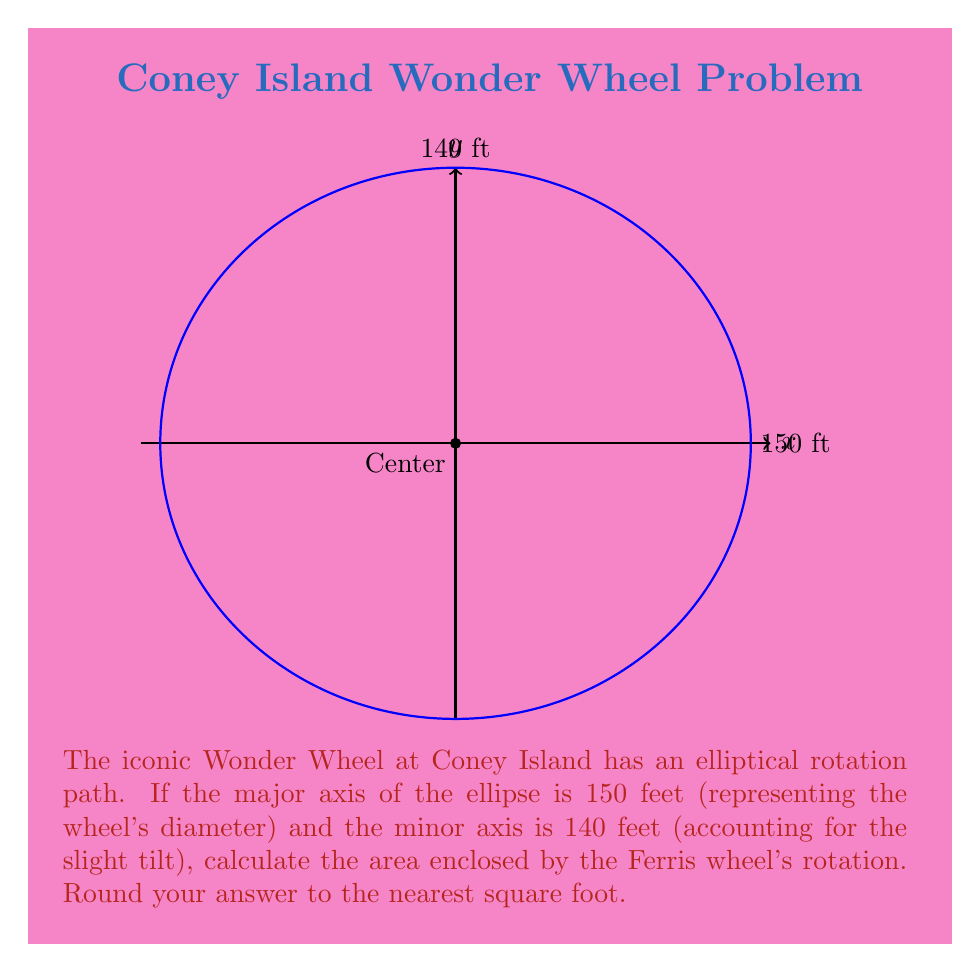Show me your answer to this math problem. To solve this problem, we'll use the formula for the area of an ellipse and follow these steps:

1) The formula for the area of an ellipse is:

   $$A = \pi ab$$

   where $a$ is half the length of the major axis and $b$ is half the length of the minor axis.

2) Given:
   - Major axis = 150 feet
   - Minor axis = 140 feet

3) Calculate $a$ and $b$:
   $a = 150 / 2 = 75$ feet
   $b = 140 / 2 = 70$ feet

4) Substitute these values into the formula:

   $$A = \pi (75)(70)$$

5) Calculate:
   $$A = \pi (5250)$$
   $$A = 16,493.36... \text{ square feet}$$

6) Rounding to the nearest square foot:
   $$A \approx 16,493 \text{ square feet}$$

This area represents the space enclosed by the Wonder Wheel's rotation, which is crucial for understanding the Ferris wheel's impact on Coney Island's skyline and its significance as a cultural landmark.
Answer: 16,493 sq ft 